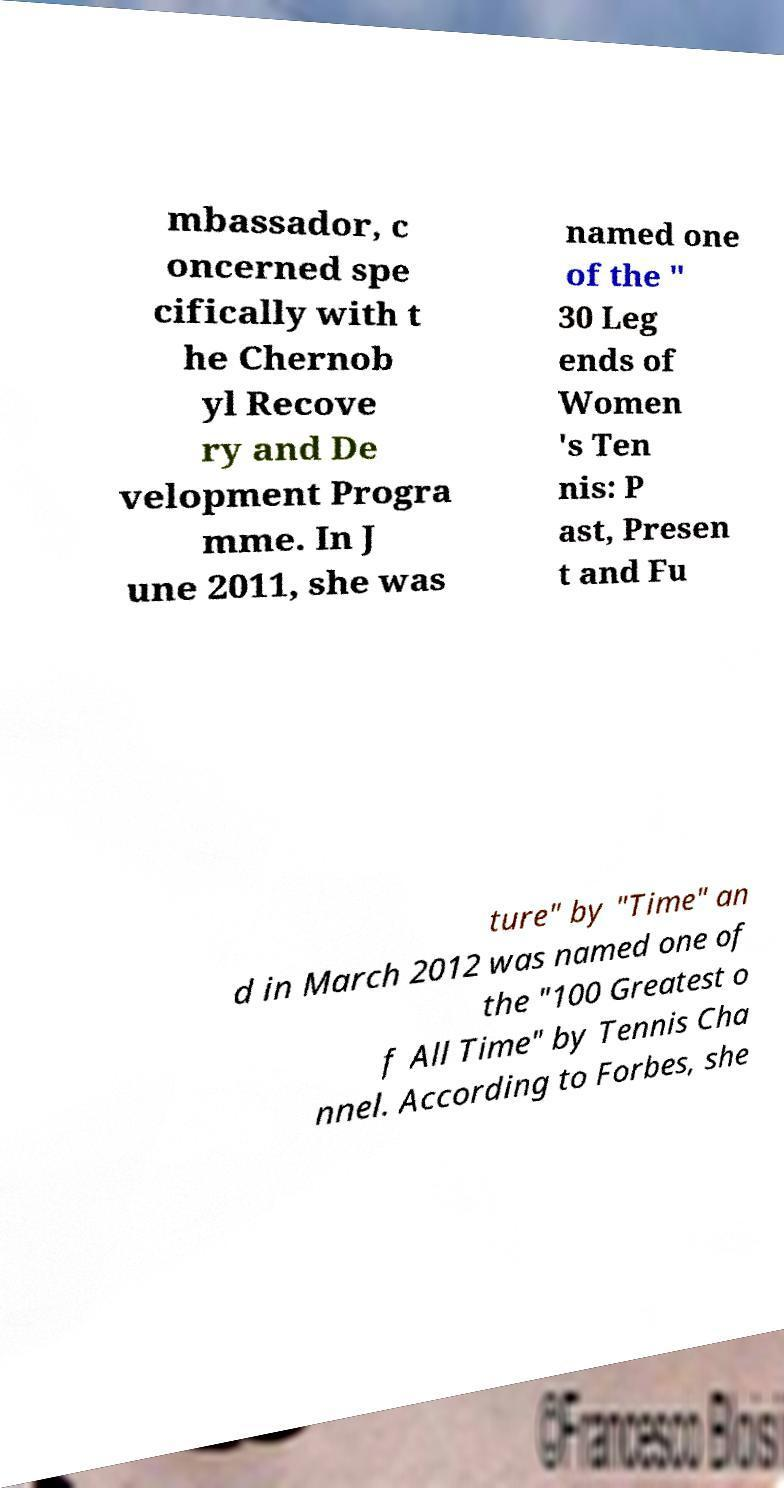I need the written content from this picture converted into text. Can you do that? mbassador, c oncerned spe cifically with t he Chernob yl Recove ry and De velopment Progra mme. In J une 2011, she was named one of the " 30 Leg ends of Women 's Ten nis: P ast, Presen t and Fu ture" by "Time" an d in March 2012 was named one of the "100 Greatest o f All Time" by Tennis Cha nnel. According to Forbes, she 